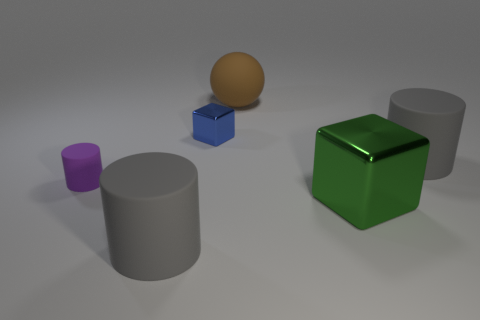Are there any cubes on the right side of the blue block?
Provide a short and direct response. Yes. What color is the matte sphere?
Your answer should be very brief. Brown. Does the big ball have the same color as the large matte object in front of the tiny rubber cylinder?
Ensure brevity in your answer.  No. Are there any brown matte cylinders of the same size as the brown matte ball?
Give a very brief answer. No. What material is the large cylinder that is on the left side of the small shiny block?
Keep it short and to the point. Rubber. Are there the same number of shiny objects to the right of the large metal object and brown rubber balls in front of the purple object?
Provide a short and direct response. Yes. Is the size of the metallic thing that is in front of the blue metal block the same as the gray object behind the tiny cylinder?
Your answer should be very brief. Yes. What number of small rubber things have the same color as the tiny metallic thing?
Make the answer very short. 0. Is the number of big cubes behind the large brown object greater than the number of small green cubes?
Offer a terse response. No. Do the green thing and the small rubber thing have the same shape?
Keep it short and to the point. No. 